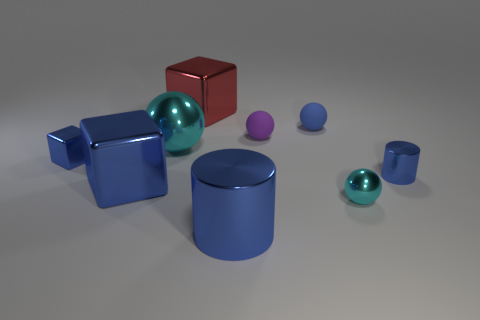What size is the red metallic block?
Keep it short and to the point. Large. Does the metallic ball to the left of the red cube have the same color as the small block?
Make the answer very short. No. Are there more purple objects in front of the large cyan thing than metallic cylinders on the right side of the tiny cyan metal thing?
Your answer should be very brief. No. Is the number of red matte things greater than the number of large red shiny cubes?
Your answer should be compact. No. What size is the object that is both behind the purple matte object and on the left side of the small purple rubber thing?
Provide a succinct answer. Large. There is a blue rubber object; what shape is it?
Provide a succinct answer. Sphere. Is there any other thing that has the same size as the purple ball?
Offer a very short reply. Yes. Is the number of big blue metallic blocks that are behind the large blue cube greater than the number of rubber things?
Your answer should be compact. No. What shape is the small blue metal thing that is behind the blue cylinder behind the big blue thing that is in front of the tiny cyan shiny thing?
Give a very brief answer. Cube. Is the size of the rubber ball that is right of the purple rubber object the same as the large blue shiny cylinder?
Provide a succinct answer. No. 